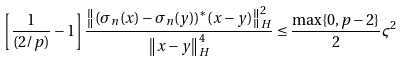<formula> <loc_0><loc_0><loc_500><loc_500>\left [ \frac { 1 } { ( 2 / p ) } - 1 \right ] \frac { \left \| ( \sigma _ { n } ( x ) - \sigma _ { n } ( y ) ) ^ { * } ( x - y ) \right \| ^ { 2 } _ { H } } { \left \| x - y \right \| ^ { 4 } _ { H } } \leq \frac { \max \{ 0 , p - 2 \} } { 2 } \varsigma ^ { 2 }</formula> 